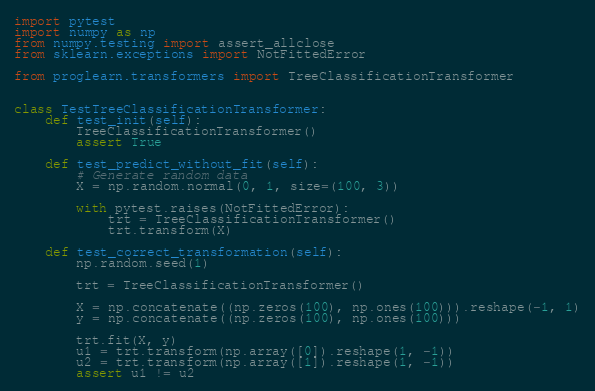<code> <loc_0><loc_0><loc_500><loc_500><_Python_>import pytest
import numpy as np
from numpy.testing import assert_allclose
from sklearn.exceptions import NotFittedError

from proglearn.transformers import TreeClassificationTransformer


class TestTreeClassificationTransformer:
    def test_init(self):
        TreeClassificationTransformer()
        assert True

    def test_predict_without_fit(self):
        # Generate random data
        X = np.random.normal(0, 1, size=(100, 3))

        with pytest.raises(NotFittedError):
            trt = TreeClassificationTransformer()
            trt.transform(X)

    def test_correct_transformation(self):
        np.random.seed(1)

        trt = TreeClassificationTransformer()

        X = np.concatenate((np.zeros(100), np.ones(100))).reshape(-1, 1)
        y = np.concatenate((np.zeros(100), np.ones(100)))

        trt.fit(X, y)
        u1 = trt.transform(np.array([0]).reshape(1, -1))
        u2 = trt.transform(np.array([1]).reshape(1, -1))
        assert u1 != u2
</code> 